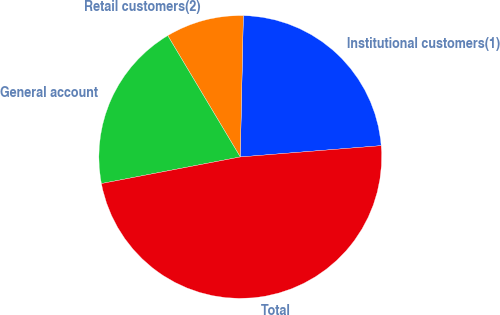Convert chart to OTSL. <chart><loc_0><loc_0><loc_500><loc_500><pie_chart><fcel>Institutional customers(1)<fcel>Retail customers(2)<fcel>General account<fcel>Total<nl><fcel>23.38%<fcel>8.92%<fcel>19.44%<fcel>48.27%<nl></chart> 